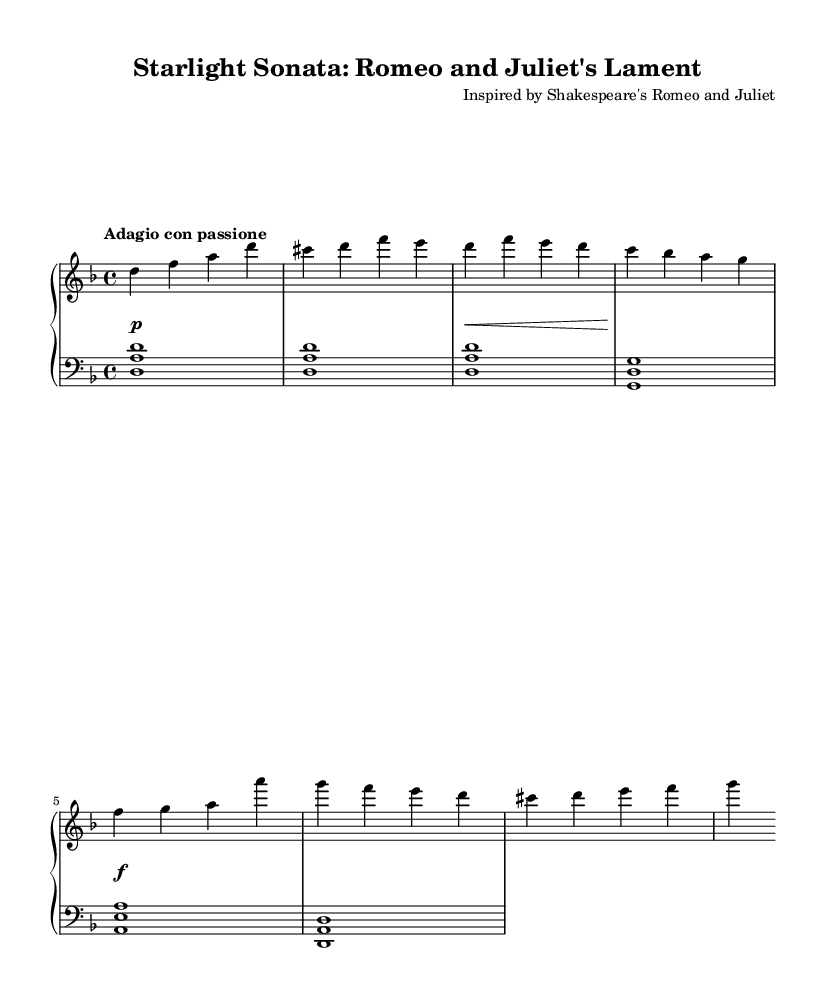What is the key signature of this music? The key signature is indicated at the beginning of the sheet music, which shows two flats. This corresponds to the key of D minor.
Answer: D minor What is the time signature of this piece? The time signature is located near the beginning and is displayed as 4/4, which means there are four beats in each measure.
Answer: 4/4 What tempo marking is given for this piece? The tempo marking is written under the title in Italian, indicating the character of the music. Here, it is marked as "Adagio con passione," meaning slowly with passion.
Answer: Adagio con passione How many distinct themes are indicated in the score? By analyzing the provided sections of the right hand, there are two themes: Theme A and Theme B are clearly labeled and displayed in the respective measures.
Answer: Two themes What dynamic markings are used throughout the piece? The dynamics are notated with symbols like p for piano (soft), f for forte (loud), and symbols for crescendos and decrescendos, found in the dynamics staff. Here, it shows soft, then loud.
Answer: Piano, forte What is the main structural division of this piece? The piece is structured in three parts: an introduction followed by Theme A and Theme B. The different sections are revealed through the distinct musical phrases and their respective introductions.
Answer: Introduction, Theme A, Theme B How does the left hand complement the right hand in this piece? By observing the notation in both staves, the left hand typically plays chords that harmonize with the melody in the right hand. This creates a fuller sound and support for the melody.
Answer: Harmonization 